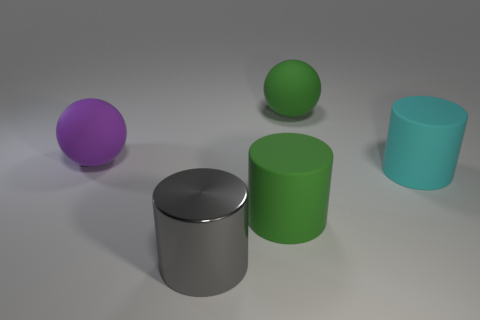How many purple things have the same size as the green sphere?
Your answer should be compact. 1. Are there fewer large green things in front of the large cyan rubber thing than green rubber cylinders?
Your answer should be very brief. No. How big is the matte cylinder on the right side of the big matte thing that is behind the big purple matte thing?
Give a very brief answer. Large. How many things are green balls or shiny things?
Offer a terse response. 2. Are there any large matte cylinders of the same color as the large shiny thing?
Your answer should be compact. No. Is the number of small green matte cubes less than the number of cyan rubber cylinders?
Make the answer very short. Yes. What number of things are either yellow rubber objects or large spheres that are right of the purple ball?
Keep it short and to the point. 1. Is there a big gray object that has the same material as the big purple object?
Keep it short and to the point. No. There is a cyan cylinder that is the same size as the shiny object; what material is it?
Provide a succinct answer. Rubber. What material is the green object left of the green matte thing that is behind the large cyan thing made of?
Give a very brief answer. Rubber. 